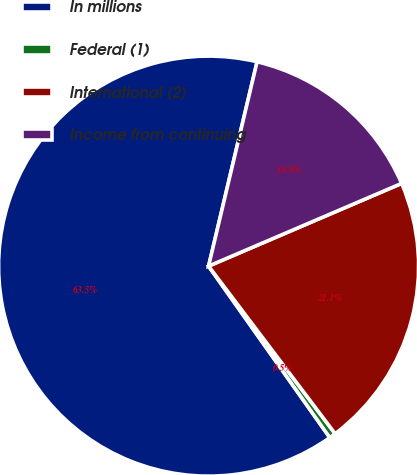Convert chart to OTSL. <chart><loc_0><loc_0><loc_500><loc_500><pie_chart><fcel>In millions<fcel>Federal (1)<fcel>International (2)<fcel>Income from continuing<nl><fcel>63.5%<fcel>0.5%<fcel>21.15%<fcel>14.85%<nl></chart> 